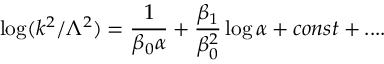Convert formula to latex. <formula><loc_0><loc_0><loc_500><loc_500>\log ( k ^ { 2 } / \Lambda ^ { 2 } ) = { \frac { 1 } { \beta _ { 0 } \alpha } } + { \frac { \beta _ { 1 } } { \beta _ { 0 } ^ { 2 } } } \log \alpha + c o n s t + \cdots</formula> 